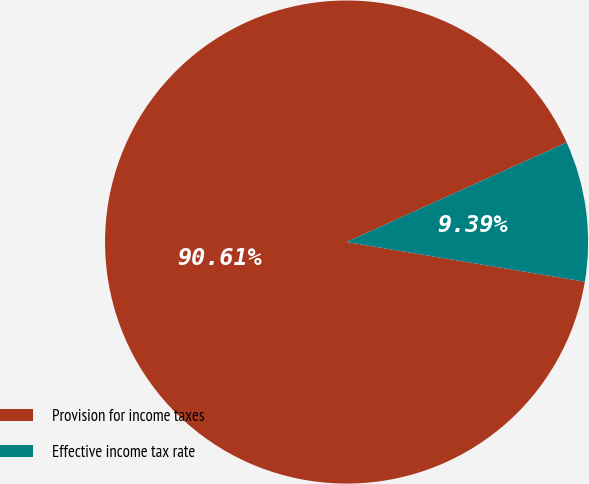<chart> <loc_0><loc_0><loc_500><loc_500><pie_chart><fcel>Provision for income taxes<fcel>Effective income tax rate<nl><fcel>90.61%<fcel>9.39%<nl></chart> 